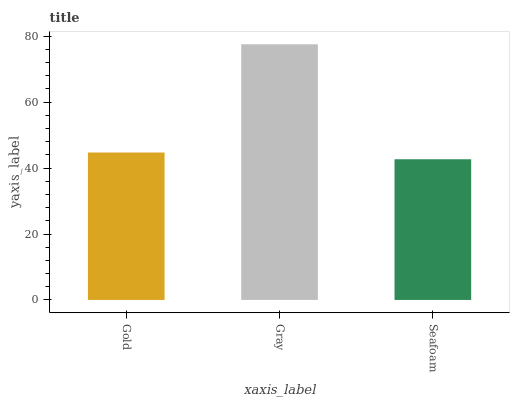Is Seafoam the minimum?
Answer yes or no. Yes. Is Gray the maximum?
Answer yes or no. Yes. Is Gray the minimum?
Answer yes or no. No. Is Seafoam the maximum?
Answer yes or no. No. Is Gray greater than Seafoam?
Answer yes or no. Yes. Is Seafoam less than Gray?
Answer yes or no. Yes. Is Seafoam greater than Gray?
Answer yes or no. No. Is Gray less than Seafoam?
Answer yes or no. No. Is Gold the high median?
Answer yes or no. Yes. Is Gold the low median?
Answer yes or no. Yes. Is Gray the high median?
Answer yes or no. No. Is Gray the low median?
Answer yes or no. No. 